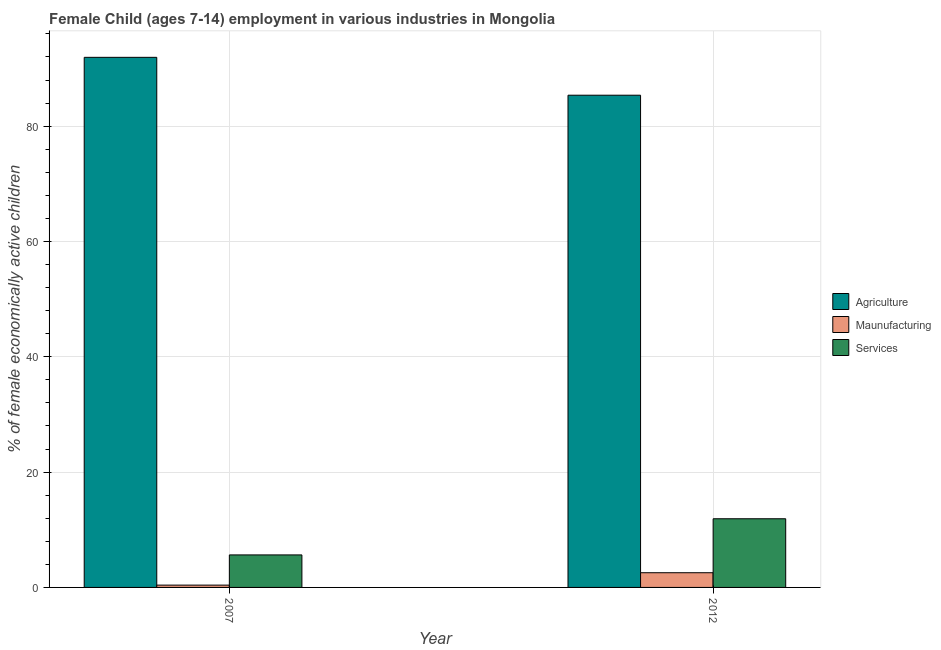How many groups of bars are there?
Your answer should be compact. 2. How many bars are there on the 2nd tick from the left?
Offer a very short reply. 3. What is the label of the 1st group of bars from the left?
Make the answer very short. 2007. In how many cases, is the number of bars for a given year not equal to the number of legend labels?
Offer a terse response. 0. Across all years, what is the maximum percentage of economically active children in services?
Offer a terse response. 11.91. Across all years, what is the minimum percentage of economically active children in services?
Give a very brief answer. 5.64. In which year was the percentage of economically active children in agriculture minimum?
Your answer should be very brief. 2012. What is the total percentage of economically active children in manufacturing in the graph?
Give a very brief answer. 2.95. What is the difference between the percentage of economically active children in services in 2007 and that in 2012?
Your answer should be compact. -6.27. What is the difference between the percentage of economically active children in services in 2007 and the percentage of economically active children in agriculture in 2012?
Provide a short and direct response. -6.27. What is the average percentage of economically active children in services per year?
Provide a succinct answer. 8.78. In the year 2007, what is the difference between the percentage of economically active children in agriculture and percentage of economically active children in services?
Provide a succinct answer. 0. What is the ratio of the percentage of economically active children in agriculture in 2007 to that in 2012?
Keep it short and to the point. 1.08. What does the 2nd bar from the left in 2012 represents?
Offer a terse response. Maunufacturing. What does the 2nd bar from the right in 2007 represents?
Your answer should be compact. Maunufacturing. Is it the case that in every year, the sum of the percentage of economically active children in agriculture and percentage of economically active children in manufacturing is greater than the percentage of economically active children in services?
Make the answer very short. Yes. Are all the bars in the graph horizontal?
Your response must be concise. No. Are the values on the major ticks of Y-axis written in scientific E-notation?
Ensure brevity in your answer.  No. Does the graph contain any zero values?
Give a very brief answer. No. Does the graph contain grids?
Provide a short and direct response. Yes. How many legend labels are there?
Your answer should be very brief. 3. How are the legend labels stacked?
Offer a terse response. Vertical. What is the title of the graph?
Your answer should be very brief. Female Child (ages 7-14) employment in various industries in Mongolia. What is the label or title of the Y-axis?
Give a very brief answer. % of female economically active children. What is the % of female economically active children of Agriculture in 2007?
Provide a succinct answer. 91.94. What is the % of female economically active children of Services in 2007?
Provide a short and direct response. 5.64. What is the % of female economically active children of Agriculture in 2012?
Your answer should be very brief. 85.37. What is the % of female economically active children in Maunufacturing in 2012?
Ensure brevity in your answer.  2.55. What is the % of female economically active children of Services in 2012?
Ensure brevity in your answer.  11.91. Across all years, what is the maximum % of female economically active children in Agriculture?
Provide a succinct answer. 91.94. Across all years, what is the maximum % of female economically active children of Maunufacturing?
Provide a short and direct response. 2.55. Across all years, what is the maximum % of female economically active children in Services?
Keep it short and to the point. 11.91. Across all years, what is the minimum % of female economically active children of Agriculture?
Your answer should be compact. 85.37. Across all years, what is the minimum % of female economically active children in Maunufacturing?
Your answer should be compact. 0.4. Across all years, what is the minimum % of female economically active children in Services?
Offer a very short reply. 5.64. What is the total % of female economically active children in Agriculture in the graph?
Offer a terse response. 177.31. What is the total % of female economically active children of Maunufacturing in the graph?
Your answer should be compact. 2.95. What is the total % of female economically active children in Services in the graph?
Your answer should be very brief. 17.55. What is the difference between the % of female economically active children in Agriculture in 2007 and that in 2012?
Offer a terse response. 6.57. What is the difference between the % of female economically active children of Maunufacturing in 2007 and that in 2012?
Offer a very short reply. -2.15. What is the difference between the % of female economically active children of Services in 2007 and that in 2012?
Offer a terse response. -6.27. What is the difference between the % of female economically active children of Agriculture in 2007 and the % of female economically active children of Maunufacturing in 2012?
Your answer should be compact. 89.39. What is the difference between the % of female economically active children of Agriculture in 2007 and the % of female economically active children of Services in 2012?
Your answer should be compact. 80.03. What is the difference between the % of female economically active children in Maunufacturing in 2007 and the % of female economically active children in Services in 2012?
Offer a terse response. -11.51. What is the average % of female economically active children in Agriculture per year?
Provide a succinct answer. 88.66. What is the average % of female economically active children of Maunufacturing per year?
Give a very brief answer. 1.48. What is the average % of female economically active children of Services per year?
Your response must be concise. 8.78. In the year 2007, what is the difference between the % of female economically active children of Agriculture and % of female economically active children of Maunufacturing?
Make the answer very short. 91.54. In the year 2007, what is the difference between the % of female economically active children of Agriculture and % of female economically active children of Services?
Offer a very short reply. 86.3. In the year 2007, what is the difference between the % of female economically active children in Maunufacturing and % of female economically active children in Services?
Give a very brief answer. -5.24. In the year 2012, what is the difference between the % of female economically active children of Agriculture and % of female economically active children of Maunufacturing?
Your answer should be very brief. 82.82. In the year 2012, what is the difference between the % of female economically active children in Agriculture and % of female economically active children in Services?
Your answer should be very brief. 73.46. In the year 2012, what is the difference between the % of female economically active children in Maunufacturing and % of female economically active children in Services?
Your answer should be very brief. -9.36. What is the ratio of the % of female economically active children of Agriculture in 2007 to that in 2012?
Offer a very short reply. 1.08. What is the ratio of the % of female economically active children of Maunufacturing in 2007 to that in 2012?
Ensure brevity in your answer.  0.16. What is the ratio of the % of female economically active children in Services in 2007 to that in 2012?
Make the answer very short. 0.47. What is the difference between the highest and the second highest % of female economically active children of Agriculture?
Provide a succinct answer. 6.57. What is the difference between the highest and the second highest % of female economically active children in Maunufacturing?
Your answer should be very brief. 2.15. What is the difference between the highest and the second highest % of female economically active children of Services?
Offer a very short reply. 6.27. What is the difference between the highest and the lowest % of female economically active children of Agriculture?
Provide a succinct answer. 6.57. What is the difference between the highest and the lowest % of female economically active children of Maunufacturing?
Provide a short and direct response. 2.15. What is the difference between the highest and the lowest % of female economically active children in Services?
Your answer should be compact. 6.27. 